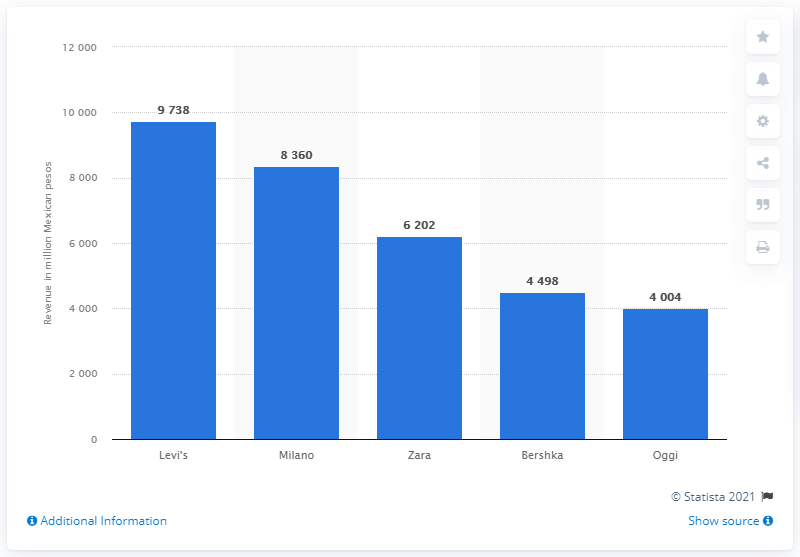Mention a couple of crucial points in this snapshot. The amount of money generated by Milano in Mexican pesos in 2016 was 83,600. Milano was the largest discount clothing retailer in Mexico in 2016. 